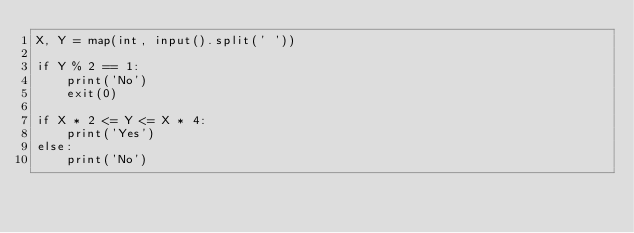Convert code to text. <code><loc_0><loc_0><loc_500><loc_500><_Python_>X, Y = map(int, input().split(' '))

if Y % 2 == 1:
    print('No')
    exit(0)

if X * 2 <= Y <= X * 4:
    print('Yes')
else:
    print('No')</code> 